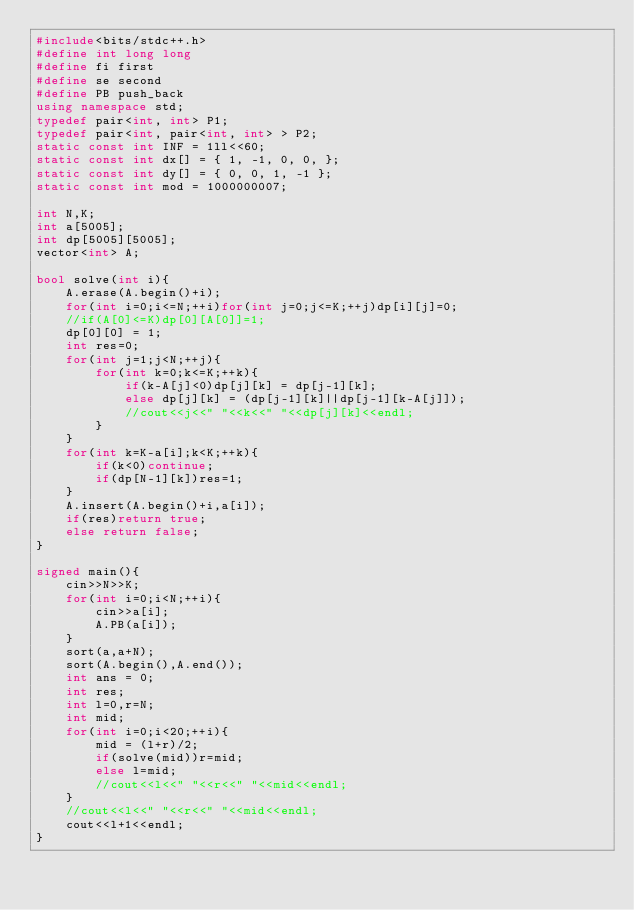<code> <loc_0><loc_0><loc_500><loc_500><_C++_>#include<bits/stdc++.h>
#define int long long
#define fi first
#define se second
#define PB push_back
using namespace std;
typedef pair<int, int> P1;
typedef pair<int, pair<int, int> > P2;
static const int INF = 1ll<<60;
static const int dx[] = { 1, -1, 0, 0, };
static const int dy[] = { 0, 0, 1, -1 };
static const int mod = 1000000007;

int N,K;
int a[5005];
int dp[5005][5005];
vector<int> A;

bool solve(int i){
    A.erase(A.begin()+i);
    for(int i=0;i<=N;++i)for(int j=0;j<=K;++j)dp[i][j]=0;
    //if(A[0]<=K)dp[0][A[0]]=1;
    dp[0][0] = 1;
    int res=0;
    for(int j=1;j<N;++j){
        for(int k=0;k<=K;++k){
            if(k-A[j]<0)dp[j][k] = dp[j-1][k];
            else dp[j][k] = (dp[j-1][k]||dp[j-1][k-A[j]]);
            //cout<<j<<" "<<k<<" "<<dp[j][k]<<endl;
        }
    }
    for(int k=K-a[i];k<K;++k){
        if(k<0)continue;
        if(dp[N-1][k])res=1;
    }
    A.insert(A.begin()+i,a[i]);
    if(res)return true;
    else return false;
}

signed main(){
    cin>>N>>K;
    for(int i=0;i<N;++i){
        cin>>a[i];
        A.PB(a[i]);
    }
    sort(a,a+N);
    sort(A.begin(),A.end());
    int ans = 0;
    int res;
    int l=0,r=N;
    int mid;
    for(int i=0;i<20;++i){
        mid = (l+r)/2;
        if(solve(mid))r=mid;
        else l=mid;
        //cout<<l<<" "<<r<<" "<<mid<<endl;
    }
    //cout<<l<<" "<<r<<" "<<mid<<endl;
    cout<<l+1<<endl;
}
</code> 